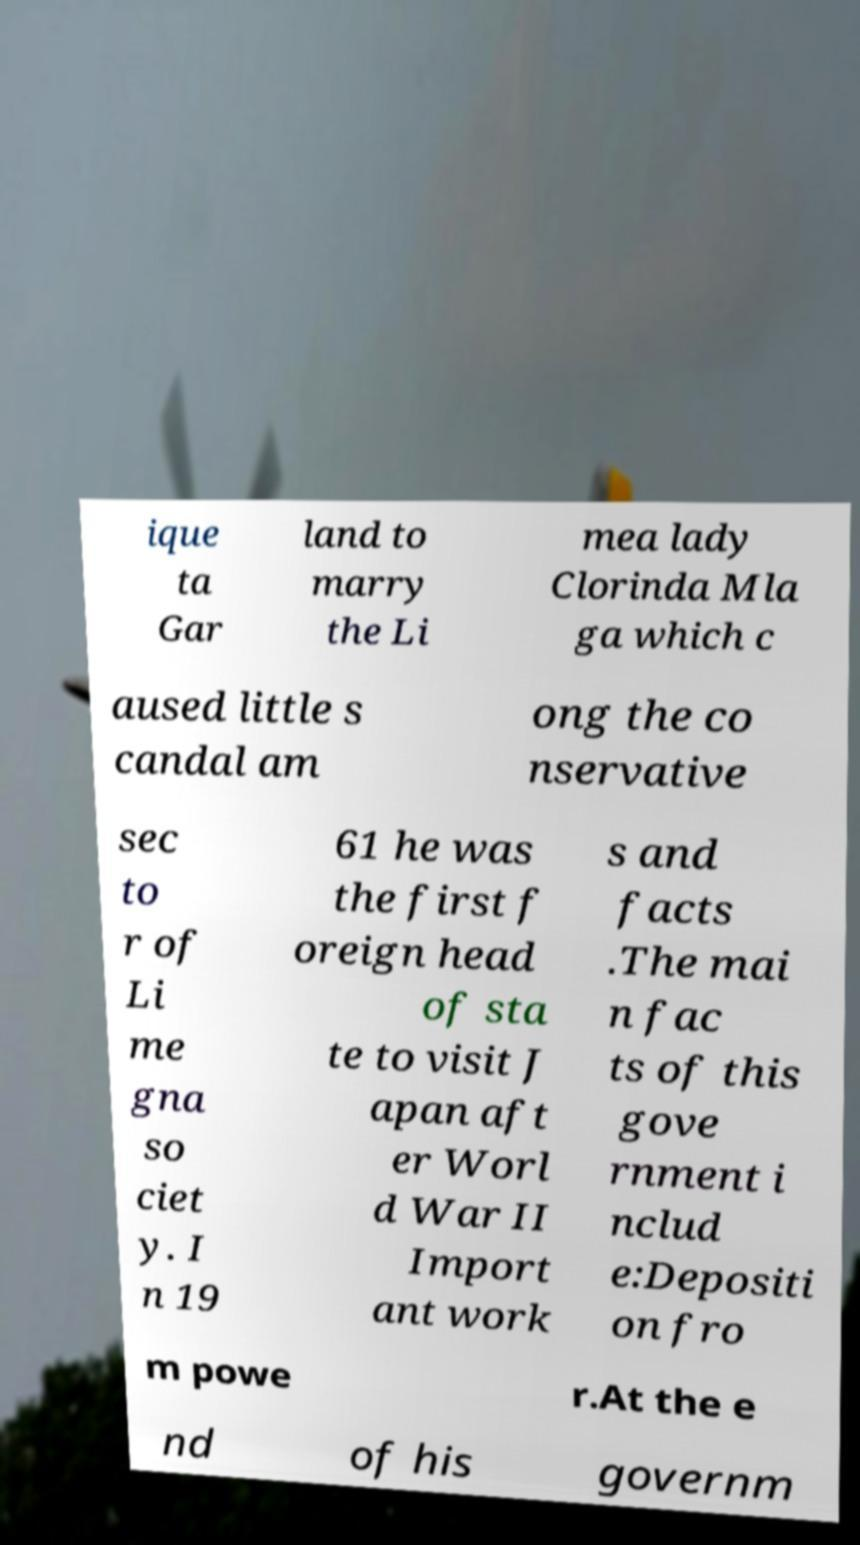For documentation purposes, I need the text within this image transcribed. Could you provide that? ique ta Gar land to marry the Li mea lady Clorinda Mla ga which c aused little s candal am ong the co nservative sec to r of Li me gna so ciet y. I n 19 61 he was the first f oreign head of sta te to visit J apan aft er Worl d War II Import ant work s and facts .The mai n fac ts of this gove rnment i nclud e:Depositi on fro m powe r.At the e nd of his governm 